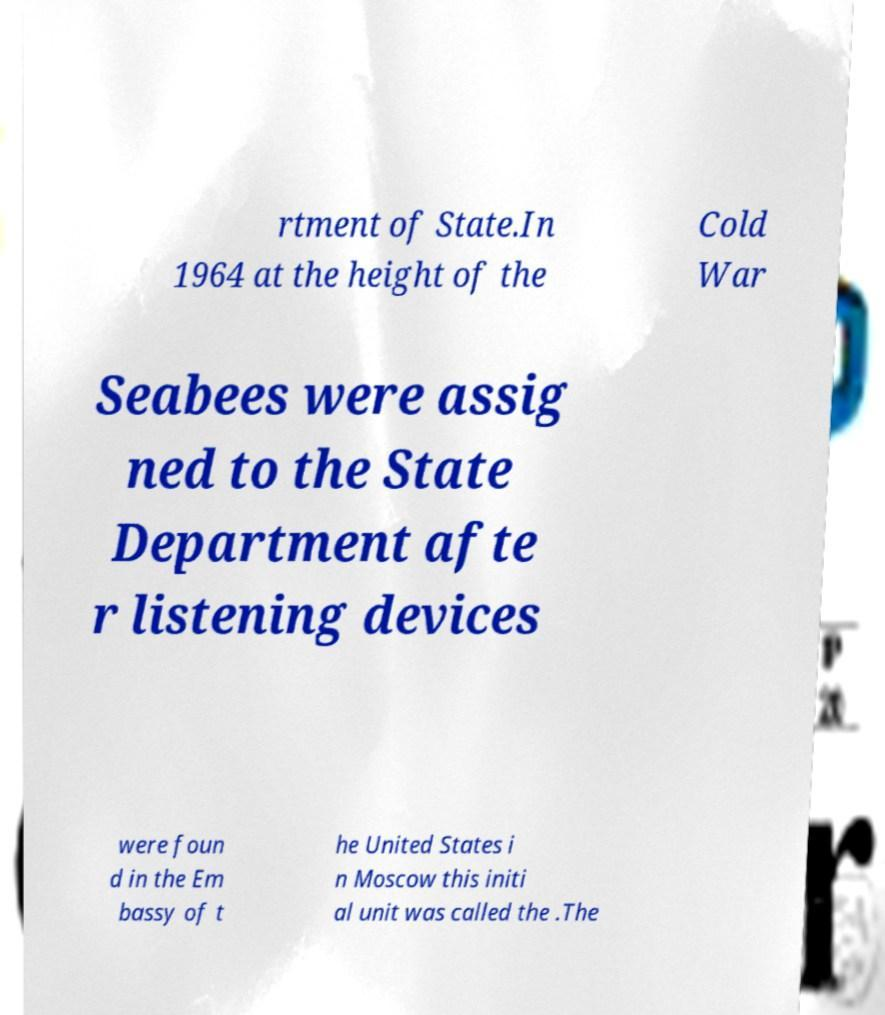Please identify and transcribe the text found in this image. rtment of State.In 1964 at the height of the Cold War Seabees were assig ned to the State Department afte r listening devices were foun d in the Em bassy of t he United States i n Moscow this initi al unit was called the .The 